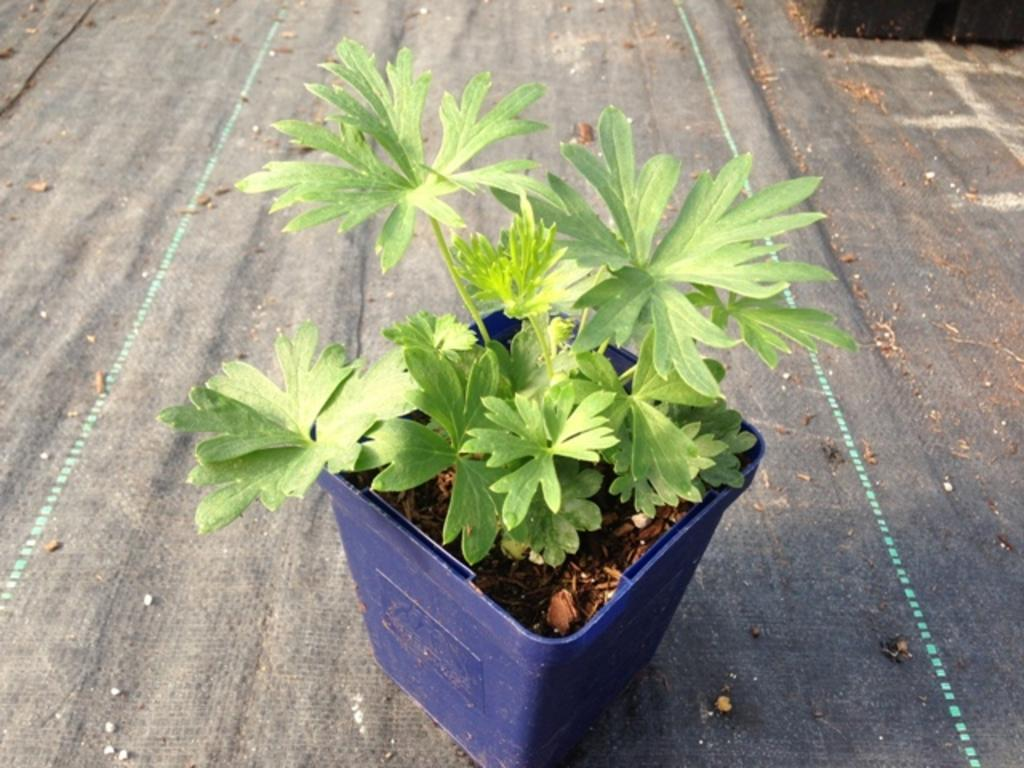What is present in the image? There is a plant in the image. Where is the plant located? The plant is on the road. What type of magic is being performed by the plant on the road? There is no magic being performed by the plant in the image; it is simply a plant located on the road. 